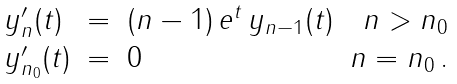<formula> <loc_0><loc_0><loc_500><loc_500>\begin{array} { l c l r } y ^ { \prime } _ { n } ( t ) & = & ( n - 1 ) \, e ^ { t } \, y _ { n - 1 } ( t ) & n > n _ { 0 } \\ y ^ { \prime } _ { n _ { 0 } } ( t ) & = & 0 & n = n _ { 0 } \, . \end{array}</formula> 